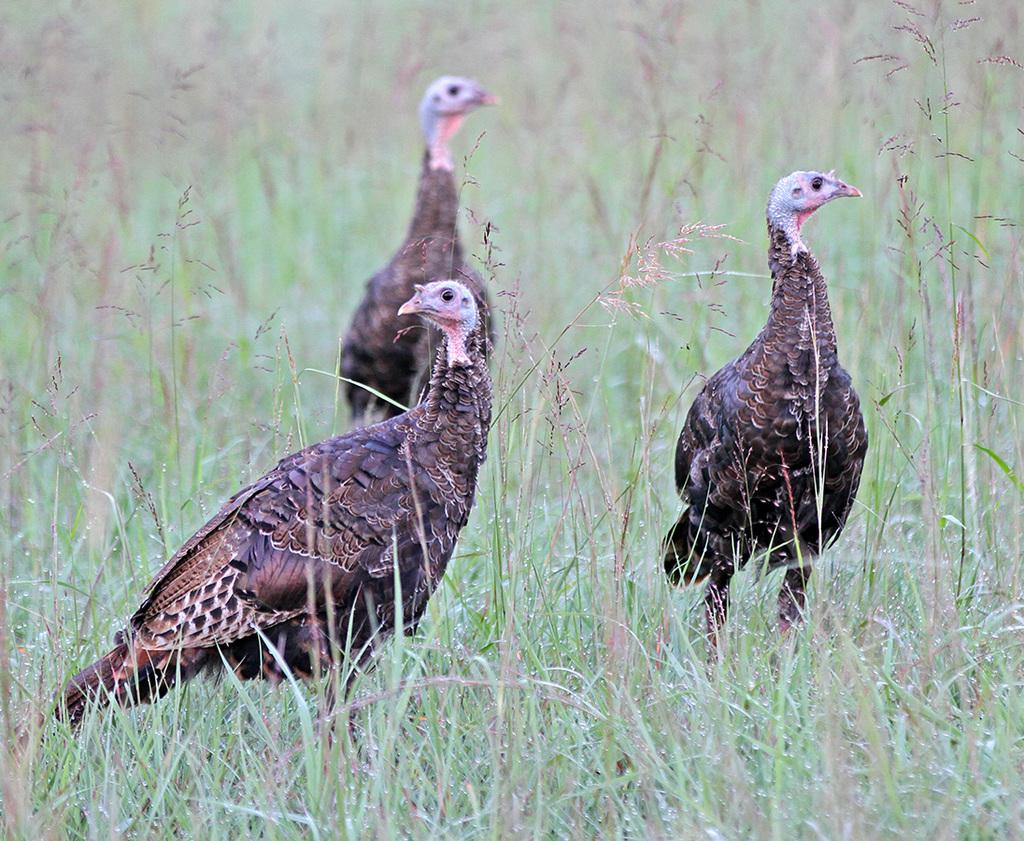What type of animals are present in the image? There are wild turkeys in the image. What colors can be seen on the wild turkeys? The wild turkeys are black and brown in color. What type of terrain is visible in the image? There is grass on the ground in the image. What type of arm is visible in the image? There is no arm present in the image; it features wild turkeys and grass. Is there a beggar asking for help in the image? There is no beggar present in the image; it features wild turkeys and grass. 